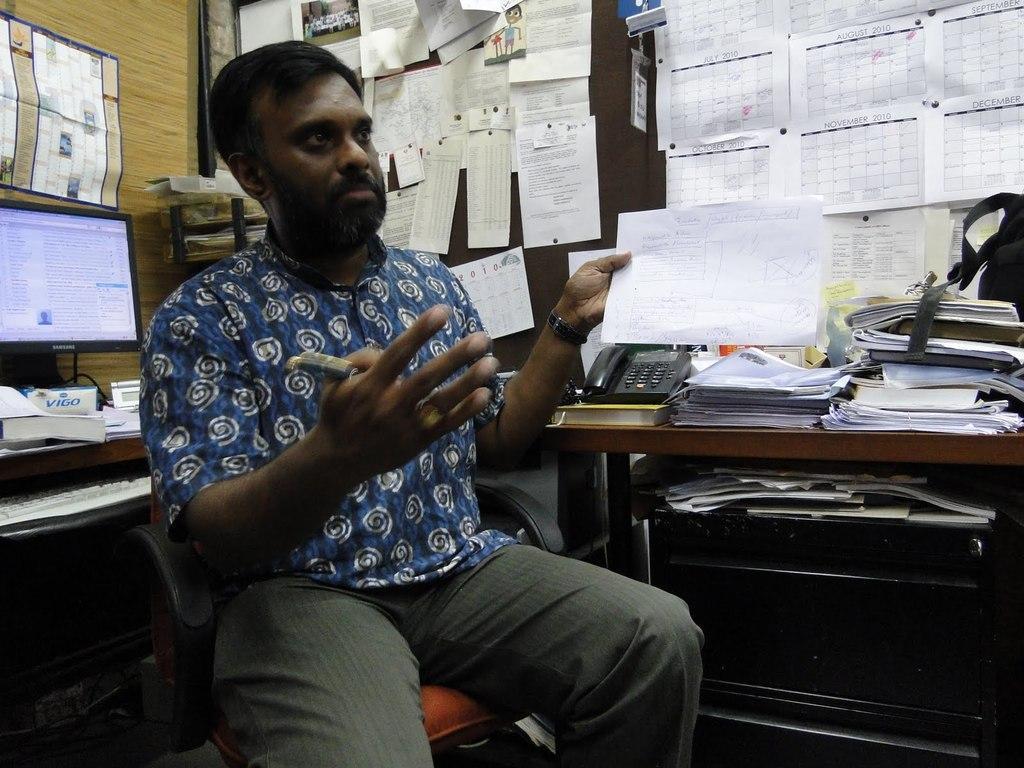Please provide a concise description of this image. In this image, there is a person wearing clothes and sitting on the chair in front of the computer. This person is holding a paper with his hand. There is a table in the bottom left of the image contains a telephone and some papers. 